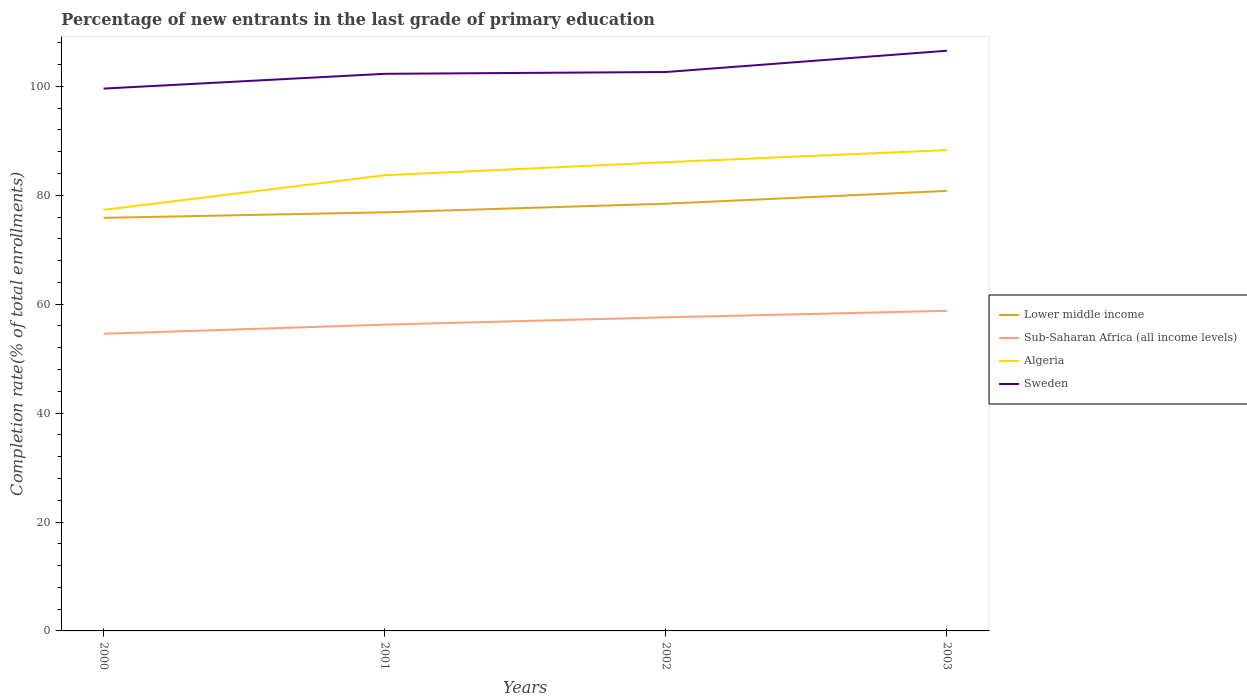Does the line corresponding to Algeria intersect with the line corresponding to Sweden?
Keep it short and to the point. No. Is the number of lines equal to the number of legend labels?
Offer a terse response. Yes. Across all years, what is the maximum percentage of new entrants in Sub-Saharan Africa (all income levels)?
Provide a short and direct response. 54.57. In which year was the percentage of new entrants in Sub-Saharan Africa (all income levels) maximum?
Your answer should be very brief. 2000. What is the total percentage of new entrants in Sub-Saharan Africa (all income levels) in the graph?
Provide a succinct answer. -2.53. What is the difference between the highest and the second highest percentage of new entrants in Algeria?
Offer a very short reply. 10.99. What is the difference between the highest and the lowest percentage of new entrants in Lower middle income?
Provide a short and direct response. 2. What is the difference between two consecutive major ticks on the Y-axis?
Provide a succinct answer. 20. Are the values on the major ticks of Y-axis written in scientific E-notation?
Keep it short and to the point. No. Where does the legend appear in the graph?
Offer a very short reply. Center right. How many legend labels are there?
Give a very brief answer. 4. What is the title of the graph?
Offer a very short reply. Percentage of new entrants in the last grade of primary education. What is the label or title of the Y-axis?
Give a very brief answer. Completion rate(% of total enrollments). What is the Completion rate(% of total enrollments) in Lower middle income in 2000?
Give a very brief answer. 75.86. What is the Completion rate(% of total enrollments) in Sub-Saharan Africa (all income levels) in 2000?
Keep it short and to the point. 54.57. What is the Completion rate(% of total enrollments) in Algeria in 2000?
Make the answer very short. 77.32. What is the Completion rate(% of total enrollments) of Sweden in 2000?
Make the answer very short. 99.59. What is the Completion rate(% of total enrollments) in Lower middle income in 2001?
Offer a very short reply. 76.87. What is the Completion rate(% of total enrollments) of Sub-Saharan Africa (all income levels) in 2001?
Keep it short and to the point. 56.25. What is the Completion rate(% of total enrollments) in Algeria in 2001?
Your answer should be very brief. 83.68. What is the Completion rate(% of total enrollments) in Sweden in 2001?
Your answer should be very brief. 102.31. What is the Completion rate(% of total enrollments) in Lower middle income in 2002?
Provide a short and direct response. 78.46. What is the Completion rate(% of total enrollments) in Sub-Saharan Africa (all income levels) in 2002?
Provide a succinct answer. 57.59. What is the Completion rate(% of total enrollments) of Algeria in 2002?
Your answer should be compact. 86.07. What is the Completion rate(% of total enrollments) of Sweden in 2002?
Provide a succinct answer. 102.64. What is the Completion rate(% of total enrollments) in Lower middle income in 2003?
Offer a terse response. 80.81. What is the Completion rate(% of total enrollments) in Sub-Saharan Africa (all income levels) in 2003?
Ensure brevity in your answer.  58.78. What is the Completion rate(% of total enrollments) in Algeria in 2003?
Provide a short and direct response. 88.3. What is the Completion rate(% of total enrollments) in Sweden in 2003?
Provide a short and direct response. 106.55. Across all years, what is the maximum Completion rate(% of total enrollments) in Lower middle income?
Make the answer very short. 80.81. Across all years, what is the maximum Completion rate(% of total enrollments) of Sub-Saharan Africa (all income levels)?
Provide a short and direct response. 58.78. Across all years, what is the maximum Completion rate(% of total enrollments) of Algeria?
Offer a terse response. 88.3. Across all years, what is the maximum Completion rate(% of total enrollments) of Sweden?
Your answer should be compact. 106.55. Across all years, what is the minimum Completion rate(% of total enrollments) in Lower middle income?
Your response must be concise. 75.86. Across all years, what is the minimum Completion rate(% of total enrollments) in Sub-Saharan Africa (all income levels)?
Provide a short and direct response. 54.57. Across all years, what is the minimum Completion rate(% of total enrollments) of Algeria?
Your response must be concise. 77.32. Across all years, what is the minimum Completion rate(% of total enrollments) of Sweden?
Your answer should be very brief. 99.59. What is the total Completion rate(% of total enrollments) of Lower middle income in the graph?
Provide a succinct answer. 311.99. What is the total Completion rate(% of total enrollments) of Sub-Saharan Africa (all income levels) in the graph?
Your answer should be compact. 227.19. What is the total Completion rate(% of total enrollments) in Algeria in the graph?
Provide a short and direct response. 335.38. What is the total Completion rate(% of total enrollments) of Sweden in the graph?
Ensure brevity in your answer.  411.08. What is the difference between the Completion rate(% of total enrollments) of Lower middle income in 2000 and that in 2001?
Give a very brief answer. -1.01. What is the difference between the Completion rate(% of total enrollments) of Sub-Saharan Africa (all income levels) in 2000 and that in 2001?
Your answer should be compact. -1.68. What is the difference between the Completion rate(% of total enrollments) of Algeria in 2000 and that in 2001?
Make the answer very short. -6.36. What is the difference between the Completion rate(% of total enrollments) of Sweden in 2000 and that in 2001?
Keep it short and to the point. -2.71. What is the difference between the Completion rate(% of total enrollments) in Lower middle income in 2000 and that in 2002?
Offer a very short reply. -2.6. What is the difference between the Completion rate(% of total enrollments) of Sub-Saharan Africa (all income levels) in 2000 and that in 2002?
Offer a terse response. -3.03. What is the difference between the Completion rate(% of total enrollments) of Algeria in 2000 and that in 2002?
Your answer should be very brief. -8.76. What is the difference between the Completion rate(% of total enrollments) in Sweden in 2000 and that in 2002?
Ensure brevity in your answer.  -3.04. What is the difference between the Completion rate(% of total enrollments) in Lower middle income in 2000 and that in 2003?
Your answer should be very brief. -4.95. What is the difference between the Completion rate(% of total enrollments) in Sub-Saharan Africa (all income levels) in 2000 and that in 2003?
Ensure brevity in your answer.  -4.21. What is the difference between the Completion rate(% of total enrollments) in Algeria in 2000 and that in 2003?
Your answer should be compact. -10.99. What is the difference between the Completion rate(% of total enrollments) in Sweden in 2000 and that in 2003?
Your response must be concise. -6.95. What is the difference between the Completion rate(% of total enrollments) in Lower middle income in 2001 and that in 2002?
Give a very brief answer. -1.59. What is the difference between the Completion rate(% of total enrollments) of Sub-Saharan Africa (all income levels) in 2001 and that in 2002?
Offer a very short reply. -1.35. What is the difference between the Completion rate(% of total enrollments) in Algeria in 2001 and that in 2002?
Make the answer very short. -2.39. What is the difference between the Completion rate(% of total enrollments) in Sweden in 2001 and that in 2002?
Your answer should be very brief. -0.33. What is the difference between the Completion rate(% of total enrollments) of Lower middle income in 2001 and that in 2003?
Provide a short and direct response. -3.94. What is the difference between the Completion rate(% of total enrollments) of Sub-Saharan Africa (all income levels) in 2001 and that in 2003?
Your answer should be very brief. -2.53. What is the difference between the Completion rate(% of total enrollments) of Algeria in 2001 and that in 2003?
Offer a terse response. -4.62. What is the difference between the Completion rate(% of total enrollments) in Sweden in 2001 and that in 2003?
Make the answer very short. -4.24. What is the difference between the Completion rate(% of total enrollments) in Lower middle income in 2002 and that in 2003?
Your answer should be compact. -2.35. What is the difference between the Completion rate(% of total enrollments) in Sub-Saharan Africa (all income levels) in 2002 and that in 2003?
Provide a short and direct response. -1.19. What is the difference between the Completion rate(% of total enrollments) in Algeria in 2002 and that in 2003?
Ensure brevity in your answer.  -2.23. What is the difference between the Completion rate(% of total enrollments) in Sweden in 2002 and that in 2003?
Keep it short and to the point. -3.91. What is the difference between the Completion rate(% of total enrollments) of Lower middle income in 2000 and the Completion rate(% of total enrollments) of Sub-Saharan Africa (all income levels) in 2001?
Provide a short and direct response. 19.61. What is the difference between the Completion rate(% of total enrollments) of Lower middle income in 2000 and the Completion rate(% of total enrollments) of Algeria in 2001?
Your answer should be very brief. -7.82. What is the difference between the Completion rate(% of total enrollments) in Lower middle income in 2000 and the Completion rate(% of total enrollments) in Sweden in 2001?
Offer a terse response. -26.45. What is the difference between the Completion rate(% of total enrollments) of Sub-Saharan Africa (all income levels) in 2000 and the Completion rate(% of total enrollments) of Algeria in 2001?
Make the answer very short. -29.11. What is the difference between the Completion rate(% of total enrollments) in Sub-Saharan Africa (all income levels) in 2000 and the Completion rate(% of total enrollments) in Sweden in 2001?
Ensure brevity in your answer.  -47.74. What is the difference between the Completion rate(% of total enrollments) in Algeria in 2000 and the Completion rate(% of total enrollments) in Sweden in 2001?
Offer a terse response. -24.99. What is the difference between the Completion rate(% of total enrollments) in Lower middle income in 2000 and the Completion rate(% of total enrollments) in Sub-Saharan Africa (all income levels) in 2002?
Your answer should be very brief. 18.26. What is the difference between the Completion rate(% of total enrollments) of Lower middle income in 2000 and the Completion rate(% of total enrollments) of Algeria in 2002?
Give a very brief answer. -10.22. What is the difference between the Completion rate(% of total enrollments) in Lower middle income in 2000 and the Completion rate(% of total enrollments) in Sweden in 2002?
Your answer should be compact. -26.78. What is the difference between the Completion rate(% of total enrollments) in Sub-Saharan Africa (all income levels) in 2000 and the Completion rate(% of total enrollments) in Algeria in 2002?
Ensure brevity in your answer.  -31.51. What is the difference between the Completion rate(% of total enrollments) in Sub-Saharan Africa (all income levels) in 2000 and the Completion rate(% of total enrollments) in Sweden in 2002?
Offer a very short reply. -48.07. What is the difference between the Completion rate(% of total enrollments) in Algeria in 2000 and the Completion rate(% of total enrollments) in Sweden in 2002?
Keep it short and to the point. -25.32. What is the difference between the Completion rate(% of total enrollments) of Lower middle income in 2000 and the Completion rate(% of total enrollments) of Sub-Saharan Africa (all income levels) in 2003?
Offer a terse response. 17.08. What is the difference between the Completion rate(% of total enrollments) of Lower middle income in 2000 and the Completion rate(% of total enrollments) of Algeria in 2003?
Ensure brevity in your answer.  -12.45. What is the difference between the Completion rate(% of total enrollments) in Lower middle income in 2000 and the Completion rate(% of total enrollments) in Sweden in 2003?
Your answer should be very brief. -30.69. What is the difference between the Completion rate(% of total enrollments) in Sub-Saharan Africa (all income levels) in 2000 and the Completion rate(% of total enrollments) in Algeria in 2003?
Ensure brevity in your answer.  -33.74. What is the difference between the Completion rate(% of total enrollments) of Sub-Saharan Africa (all income levels) in 2000 and the Completion rate(% of total enrollments) of Sweden in 2003?
Your response must be concise. -51.98. What is the difference between the Completion rate(% of total enrollments) in Algeria in 2000 and the Completion rate(% of total enrollments) in Sweden in 2003?
Offer a terse response. -29.23. What is the difference between the Completion rate(% of total enrollments) in Lower middle income in 2001 and the Completion rate(% of total enrollments) in Sub-Saharan Africa (all income levels) in 2002?
Provide a short and direct response. 19.27. What is the difference between the Completion rate(% of total enrollments) of Lower middle income in 2001 and the Completion rate(% of total enrollments) of Algeria in 2002?
Your answer should be compact. -9.21. What is the difference between the Completion rate(% of total enrollments) in Lower middle income in 2001 and the Completion rate(% of total enrollments) in Sweden in 2002?
Keep it short and to the point. -25.77. What is the difference between the Completion rate(% of total enrollments) in Sub-Saharan Africa (all income levels) in 2001 and the Completion rate(% of total enrollments) in Algeria in 2002?
Keep it short and to the point. -29.83. What is the difference between the Completion rate(% of total enrollments) in Sub-Saharan Africa (all income levels) in 2001 and the Completion rate(% of total enrollments) in Sweden in 2002?
Keep it short and to the point. -46.39. What is the difference between the Completion rate(% of total enrollments) of Algeria in 2001 and the Completion rate(% of total enrollments) of Sweden in 2002?
Keep it short and to the point. -18.95. What is the difference between the Completion rate(% of total enrollments) of Lower middle income in 2001 and the Completion rate(% of total enrollments) of Sub-Saharan Africa (all income levels) in 2003?
Make the answer very short. 18.09. What is the difference between the Completion rate(% of total enrollments) of Lower middle income in 2001 and the Completion rate(% of total enrollments) of Algeria in 2003?
Offer a terse response. -11.43. What is the difference between the Completion rate(% of total enrollments) of Lower middle income in 2001 and the Completion rate(% of total enrollments) of Sweden in 2003?
Your answer should be compact. -29.68. What is the difference between the Completion rate(% of total enrollments) of Sub-Saharan Africa (all income levels) in 2001 and the Completion rate(% of total enrollments) of Algeria in 2003?
Keep it short and to the point. -32.05. What is the difference between the Completion rate(% of total enrollments) in Sub-Saharan Africa (all income levels) in 2001 and the Completion rate(% of total enrollments) in Sweden in 2003?
Your answer should be very brief. -50.3. What is the difference between the Completion rate(% of total enrollments) of Algeria in 2001 and the Completion rate(% of total enrollments) of Sweden in 2003?
Offer a very short reply. -22.86. What is the difference between the Completion rate(% of total enrollments) of Lower middle income in 2002 and the Completion rate(% of total enrollments) of Sub-Saharan Africa (all income levels) in 2003?
Offer a very short reply. 19.68. What is the difference between the Completion rate(% of total enrollments) of Lower middle income in 2002 and the Completion rate(% of total enrollments) of Algeria in 2003?
Your answer should be compact. -9.85. What is the difference between the Completion rate(% of total enrollments) of Lower middle income in 2002 and the Completion rate(% of total enrollments) of Sweden in 2003?
Give a very brief answer. -28.09. What is the difference between the Completion rate(% of total enrollments) of Sub-Saharan Africa (all income levels) in 2002 and the Completion rate(% of total enrollments) of Algeria in 2003?
Offer a very short reply. -30.71. What is the difference between the Completion rate(% of total enrollments) in Sub-Saharan Africa (all income levels) in 2002 and the Completion rate(% of total enrollments) in Sweden in 2003?
Keep it short and to the point. -48.95. What is the difference between the Completion rate(% of total enrollments) in Algeria in 2002 and the Completion rate(% of total enrollments) in Sweden in 2003?
Make the answer very short. -20.47. What is the average Completion rate(% of total enrollments) in Lower middle income per year?
Give a very brief answer. 78. What is the average Completion rate(% of total enrollments) in Sub-Saharan Africa (all income levels) per year?
Your answer should be very brief. 56.8. What is the average Completion rate(% of total enrollments) in Algeria per year?
Provide a short and direct response. 83.84. What is the average Completion rate(% of total enrollments) in Sweden per year?
Ensure brevity in your answer.  102.77. In the year 2000, what is the difference between the Completion rate(% of total enrollments) in Lower middle income and Completion rate(% of total enrollments) in Sub-Saharan Africa (all income levels)?
Offer a very short reply. 21.29. In the year 2000, what is the difference between the Completion rate(% of total enrollments) of Lower middle income and Completion rate(% of total enrollments) of Algeria?
Offer a very short reply. -1.46. In the year 2000, what is the difference between the Completion rate(% of total enrollments) in Lower middle income and Completion rate(% of total enrollments) in Sweden?
Provide a succinct answer. -23.73. In the year 2000, what is the difference between the Completion rate(% of total enrollments) of Sub-Saharan Africa (all income levels) and Completion rate(% of total enrollments) of Algeria?
Provide a succinct answer. -22.75. In the year 2000, what is the difference between the Completion rate(% of total enrollments) in Sub-Saharan Africa (all income levels) and Completion rate(% of total enrollments) in Sweden?
Offer a very short reply. -45.02. In the year 2000, what is the difference between the Completion rate(% of total enrollments) of Algeria and Completion rate(% of total enrollments) of Sweden?
Your response must be concise. -22.27. In the year 2001, what is the difference between the Completion rate(% of total enrollments) of Lower middle income and Completion rate(% of total enrollments) of Sub-Saharan Africa (all income levels)?
Your answer should be very brief. 20.62. In the year 2001, what is the difference between the Completion rate(% of total enrollments) in Lower middle income and Completion rate(% of total enrollments) in Algeria?
Your response must be concise. -6.81. In the year 2001, what is the difference between the Completion rate(% of total enrollments) of Lower middle income and Completion rate(% of total enrollments) of Sweden?
Ensure brevity in your answer.  -25.44. In the year 2001, what is the difference between the Completion rate(% of total enrollments) of Sub-Saharan Africa (all income levels) and Completion rate(% of total enrollments) of Algeria?
Offer a very short reply. -27.43. In the year 2001, what is the difference between the Completion rate(% of total enrollments) of Sub-Saharan Africa (all income levels) and Completion rate(% of total enrollments) of Sweden?
Ensure brevity in your answer.  -46.06. In the year 2001, what is the difference between the Completion rate(% of total enrollments) in Algeria and Completion rate(% of total enrollments) in Sweden?
Offer a very short reply. -18.62. In the year 2002, what is the difference between the Completion rate(% of total enrollments) in Lower middle income and Completion rate(% of total enrollments) in Sub-Saharan Africa (all income levels)?
Keep it short and to the point. 20.86. In the year 2002, what is the difference between the Completion rate(% of total enrollments) in Lower middle income and Completion rate(% of total enrollments) in Algeria?
Give a very brief answer. -7.62. In the year 2002, what is the difference between the Completion rate(% of total enrollments) in Lower middle income and Completion rate(% of total enrollments) in Sweden?
Provide a succinct answer. -24.18. In the year 2002, what is the difference between the Completion rate(% of total enrollments) of Sub-Saharan Africa (all income levels) and Completion rate(% of total enrollments) of Algeria?
Provide a succinct answer. -28.48. In the year 2002, what is the difference between the Completion rate(% of total enrollments) in Sub-Saharan Africa (all income levels) and Completion rate(% of total enrollments) in Sweden?
Make the answer very short. -45.04. In the year 2002, what is the difference between the Completion rate(% of total enrollments) of Algeria and Completion rate(% of total enrollments) of Sweden?
Provide a short and direct response. -16.56. In the year 2003, what is the difference between the Completion rate(% of total enrollments) of Lower middle income and Completion rate(% of total enrollments) of Sub-Saharan Africa (all income levels)?
Keep it short and to the point. 22.02. In the year 2003, what is the difference between the Completion rate(% of total enrollments) of Lower middle income and Completion rate(% of total enrollments) of Algeria?
Your answer should be compact. -7.5. In the year 2003, what is the difference between the Completion rate(% of total enrollments) of Lower middle income and Completion rate(% of total enrollments) of Sweden?
Provide a short and direct response. -25.74. In the year 2003, what is the difference between the Completion rate(% of total enrollments) in Sub-Saharan Africa (all income levels) and Completion rate(% of total enrollments) in Algeria?
Provide a succinct answer. -29.52. In the year 2003, what is the difference between the Completion rate(% of total enrollments) in Sub-Saharan Africa (all income levels) and Completion rate(% of total enrollments) in Sweden?
Provide a succinct answer. -47.77. In the year 2003, what is the difference between the Completion rate(% of total enrollments) in Algeria and Completion rate(% of total enrollments) in Sweden?
Your answer should be very brief. -18.24. What is the ratio of the Completion rate(% of total enrollments) in Lower middle income in 2000 to that in 2001?
Your response must be concise. 0.99. What is the ratio of the Completion rate(% of total enrollments) in Sub-Saharan Africa (all income levels) in 2000 to that in 2001?
Provide a short and direct response. 0.97. What is the ratio of the Completion rate(% of total enrollments) of Algeria in 2000 to that in 2001?
Your answer should be compact. 0.92. What is the ratio of the Completion rate(% of total enrollments) in Sweden in 2000 to that in 2001?
Give a very brief answer. 0.97. What is the ratio of the Completion rate(% of total enrollments) of Lower middle income in 2000 to that in 2002?
Make the answer very short. 0.97. What is the ratio of the Completion rate(% of total enrollments) of Sub-Saharan Africa (all income levels) in 2000 to that in 2002?
Give a very brief answer. 0.95. What is the ratio of the Completion rate(% of total enrollments) in Algeria in 2000 to that in 2002?
Offer a terse response. 0.9. What is the ratio of the Completion rate(% of total enrollments) in Sweden in 2000 to that in 2002?
Ensure brevity in your answer.  0.97. What is the ratio of the Completion rate(% of total enrollments) in Lower middle income in 2000 to that in 2003?
Provide a succinct answer. 0.94. What is the ratio of the Completion rate(% of total enrollments) of Sub-Saharan Africa (all income levels) in 2000 to that in 2003?
Give a very brief answer. 0.93. What is the ratio of the Completion rate(% of total enrollments) in Algeria in 2000 to that in 2003?
Your answer should be very brief. 0.88. What is the ratio of the Completion rate(% of total enrollments) of Sweden in 2000 to that in 2003?
Your answer should be very brief. 0.93. What is the ratio of the Completion rate(% of total enrollments) in Lower middle income in 2001 to that in 2002?
Provide a short and direct response. 0.98. What is the ratio of the Completion rate(% of total enrollments) of Sub-Saharan Africa (all income levels) in 2001 to that in 2002?
Offer a terse response. 0.98. What is the ratio of the Completion rate(% of total enrollments) of Algeria in 2001 to that in 2002?
Ensure brevity in your answer.  0.97. What is the ratio of the Completion rate(% of total enrollments) of Lower middle income in 2001 to that in 2003?
Your answer should be very brief. 0.95. What is the ratio of the Completion rate(% of total enrollments) of Sub-Saharan Africa (all income levels) in 2001 to that in 2003?
Your answer should be compact. 0.96. What is the ratio of the Completion rate(% of total enrollments) of Algeria in 2001 to that in 2003?
Give a very brief answer. 0.95. What is the ratio of the Completion rate(% of total enrollments) in Sweden in 2001 to that in 2003?
Your response must be concise. 0.96. What is the ratio of the Completion rate(% of total enrollments) of Lower middle income in 2002 to that in 2003?
Your answer should be very brief. 0.97. What is the ratio of the Completion rate(% of total enrollments) in Sub-Saharan Africa (all income levels) in 2002 to that in 2003?
Offer a very short reply. 0.98. What is the ratio of the Completion rate(% of total enrollments) in Algeria in 2002 to that in 2003?
Make the answer very short. 0.97. What is the ratio of the Completion rate(% of total enrollments) in Sweden in 2002 to that in 2003?
Ensure brevity in your answer.  0.96. What is the difference between the highest and the second highest Completion rate(% of total enrollments) of Lower middle income?
Offer a very short reply. 2.35. What is the difference between the highest and the second highest Completion rate(% of total enrollments) of Sub-Saharan Africa (all income levels)?
Provide a short and direct response. 1.19. What is the difference between the highest and the second highest Completion rate(% of total enrollments) in Algeria?
Make the answer very short. 2.23. What is the difference between the highest and the second highest Completion rate(% of total enrollments) of Sweden?
Make the answer very short. 3.91. What is the difference between the highest and the lowest Completion rate(% of total enrollments) of Lower middle income?
Offer a terse response. 4.95. What is the difference between the highest and the lowest Completion rate(% of total enrollments) of Sub-Saharan Africa (all income levels)?
Your answer should be compact. 4.21. What is the difference between the highest and the lowest Completion rate(% of total enrollments) of Algeria?
Keep it short and to the point. 10.99. What is the difference between the highest and the lowest Completion rate(% of total enrollments) in Sweden?
Provide a short and direct response. 6.95. 